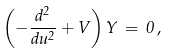Convert formula to latex. <formula><loc_0><loc_0><loc_500><loc_500>\left ( - \frac { d ^ { 2 } } { d u ^ { 2 } } + V \right ) Y \, = \, 0 \, ,</formula> 